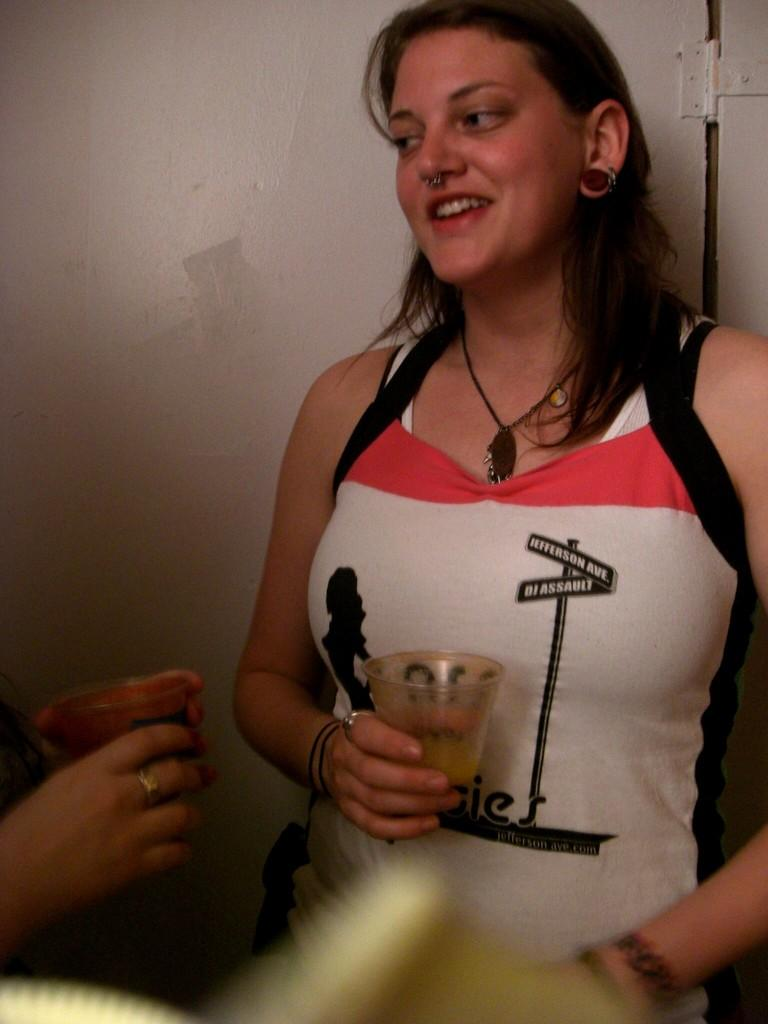What is the main subject in the foreground of the image? There is a woman standing in the foreground of the image. What is the woman holding in her hand? The woman is holding a glass. Can you describe the person on the left side of the image? The person on the left side of the image is also holding a glass. What can be seen in the background of the image? There is a wall visible in the background of the image. What type of feather can be seen on the woman's skin in the image? There is no feather or reference to skin visible in the image. 